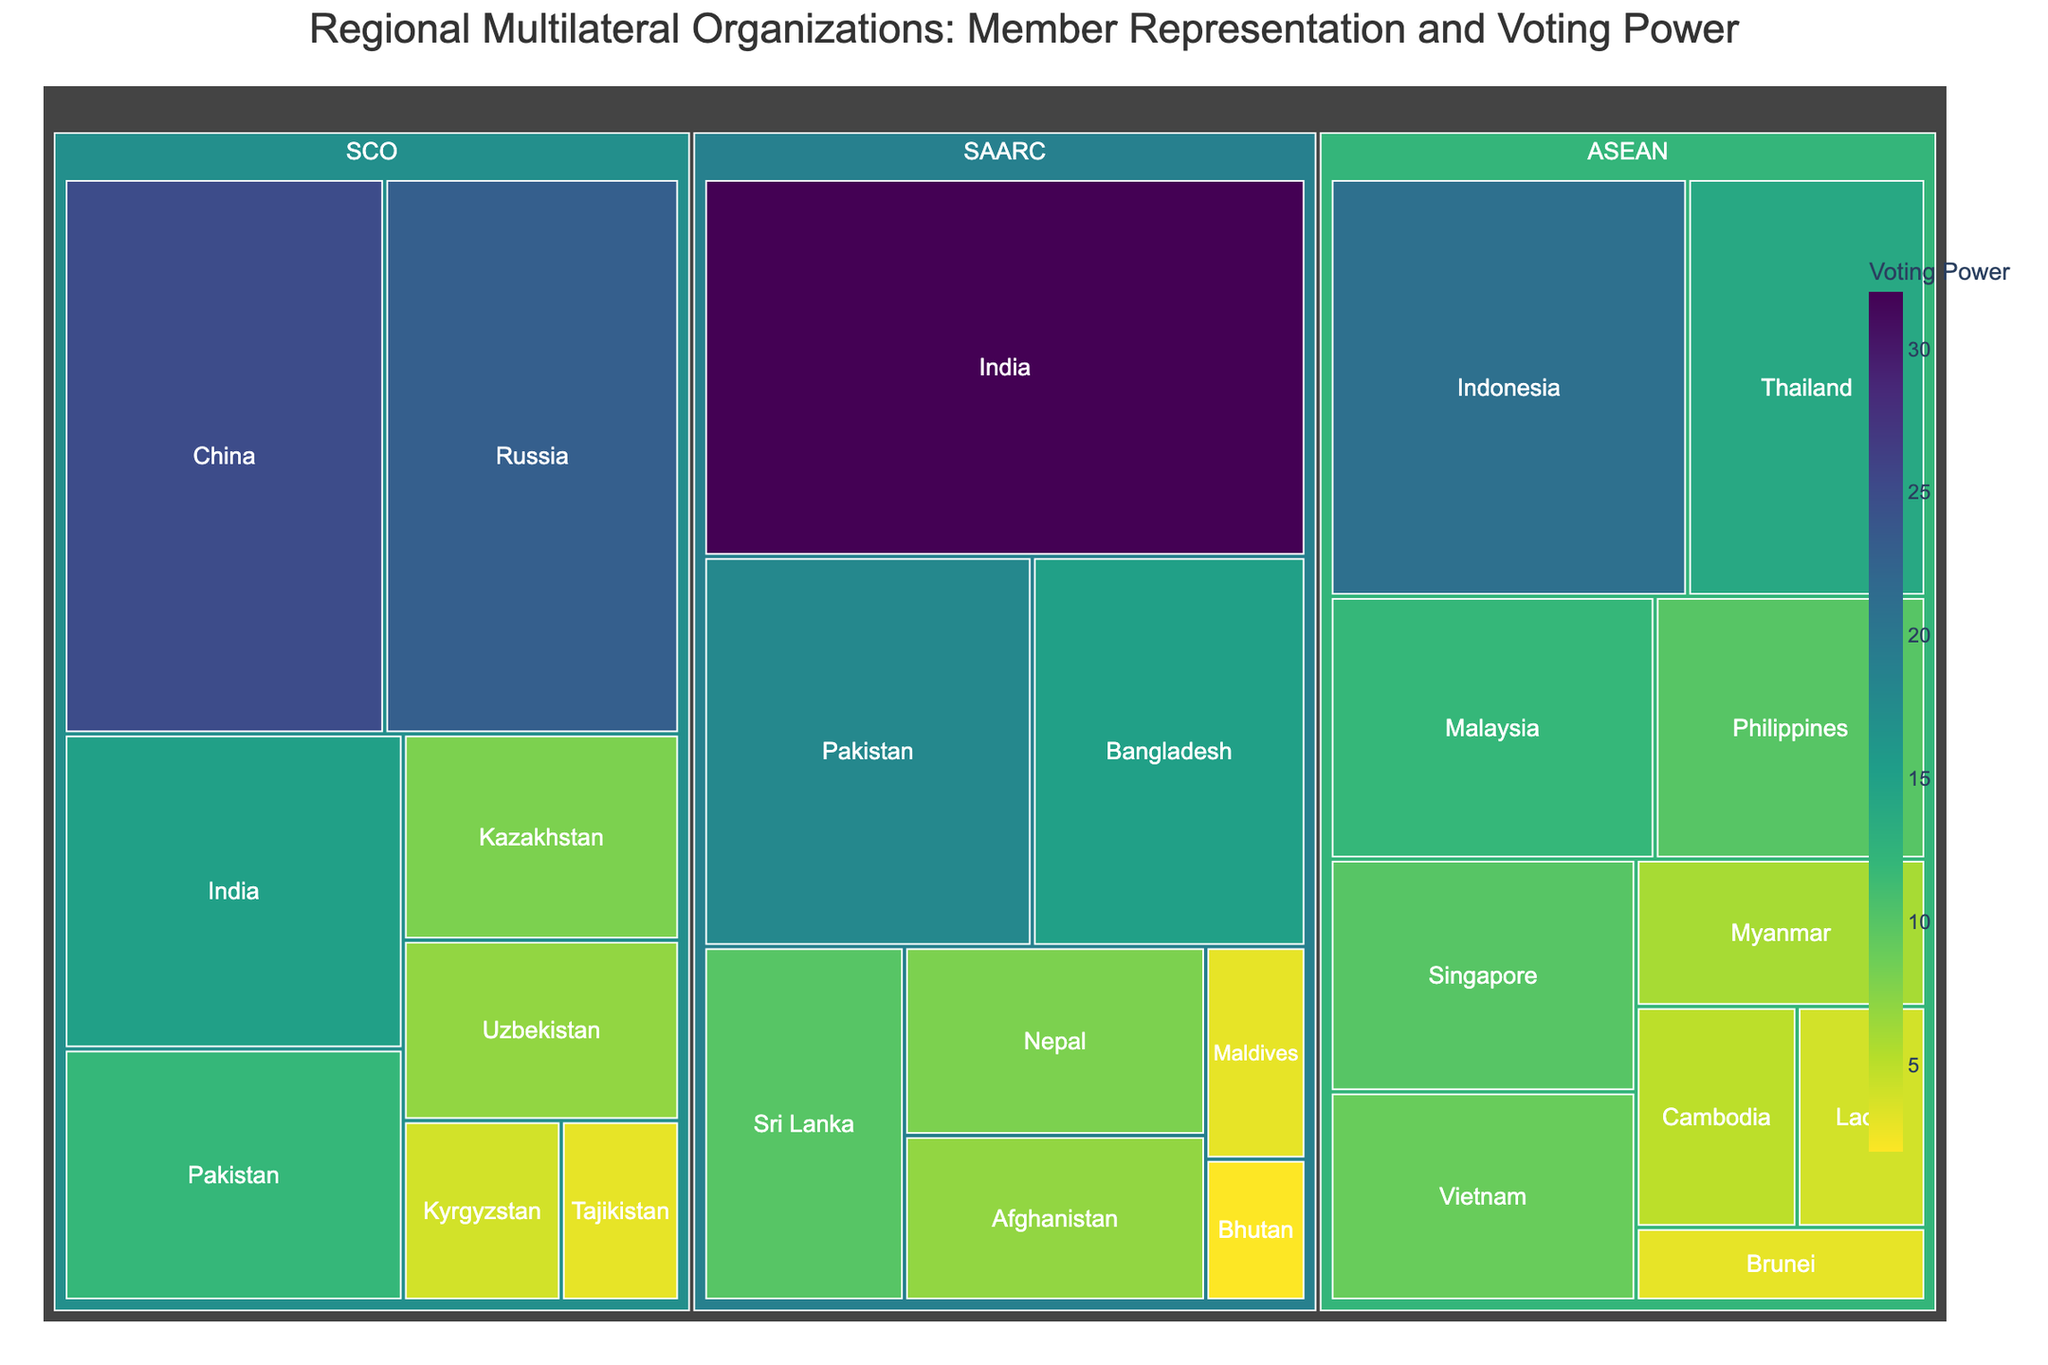What is the title of the treemap? The title of the figure is displayed at the top, usually in a larger and bold font to distinguish it from other text.
Answer: Regional Multilateral Organizations: Member Representation and Voting Power Which country has the highest voting power in the SCO? Look for the country with the largest size or darkest color within the SCO section of the treemap, indicating the highest voting power.
Answer: China How many countries are represented in ASEAN? Each distinct segment within the ASEAN section of the treemap represents a country. Count these segments.
Answer: 10 What is the combined voting power of Thailand and Singapore in ASEAN? Identify the voting power values for Thailand and Singapore in ASEAN and sum them up (14 + 10).
Answer: 24 Which organization has the most equal distribution of voting power among its member countries? Compare the size and shading of the segments for each organization. The organization with segments of similar size and color likely has a more equal distribution.
Answer: ASEAN Which country has less voting power: Laos or Tajikistan? Locate and compare the segments for Laos (ASEAN) and Tajikistan (SCO) on the treemap.
Answer: Tajikistan What is the difference in voting power between India and Pakistan in SAARC? Identify the voting power for India and Pakistan in SAARC and subtract the smaller value from the larger value (32 - 18).
Answer: 14 Which member country of SAARC has the lowest voting power? Look for the smallest segment in the SAARC section.
Answer: Bhutan What is the sum of the voting power for all member countries in the SCO? Add up the voting power values for all eight member countries in the SCO (25 + 23 + 15 + 12 + 8 + 7 + 4 + 3).
Answer: 97 How does the voting power of Indonesia in ASEAN compare to India in the SCO? Compare the voting power values for Indonesia in ASEAN (21) and India in SCO (15).
Answer: Indonesia has more voting power than India in SCO 